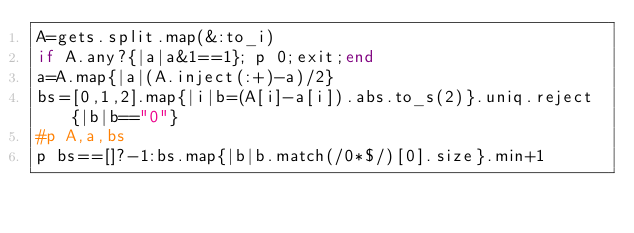Convert code to text. <code><loc_0><loc_0><loc_500><loc_500><_Ruby_>A=gets.split.map(&:to_i)
if A.any?{|a|a&1==1}; p 0;exit;end
a=A.map{|a|(A.inject(:+)-a)/2}
bs=[0,1,2].map{|i|b=(A[i]-a[i]).abs.to_s(2)}.uniq.reject{|b|b=="0"}
#p A,a,bs
p bs==[]?-1:bs.map{|b|b.match(/0*$/)[0].size}.min+1
</code> 